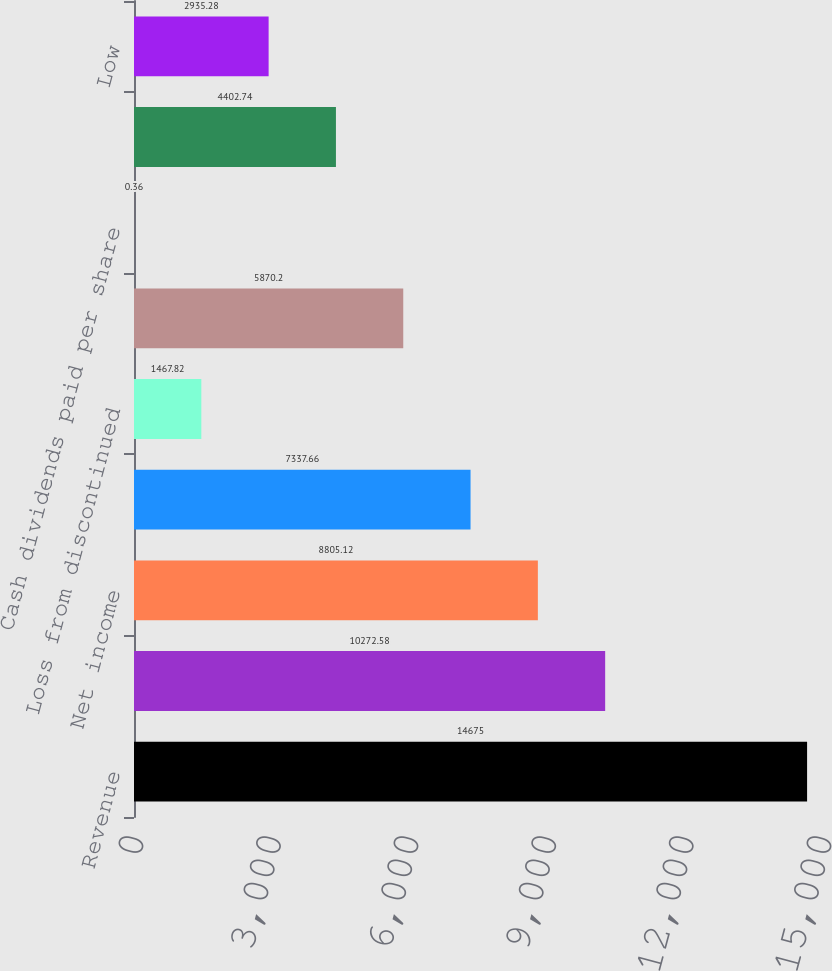Convert chart to OTSL. <chart><loc_0><loc_0><loc_500><loc_500><bar_chart><fcel>Revenue<fcel>Operating income<fcel>Net income<fcel>Income from continuing<fcel>Loss from discontinued<fcel>Net income attributable to<fcel>Cash dividends paid per share<fcel>High<fcel>Low<nl><fcel>14675<fcel>10272.6<fcel>8805.12<fcel>7337.66<fcel>1467.82<fcel>5870.2<fcel>0.36<fcel>4402.74<fcel>2935.28<nl></chart> 